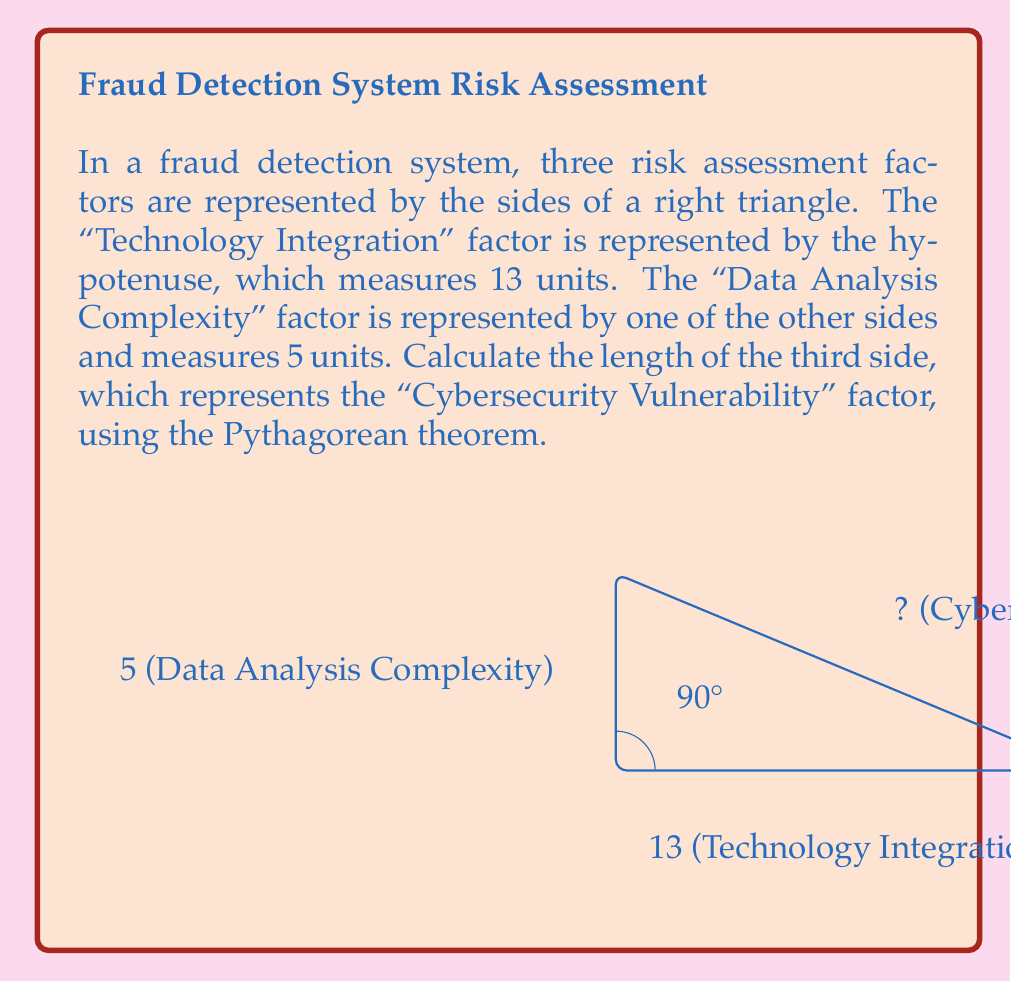Can you solve this math problem? To solve this problem, we'll use the Pythagorean theorem, which states that in a right triangle, the square of the hypotenuse is equal to the sum of squares of the other two sides.

Let's define our variables:
- $a$ = Cybersecurity Vulnerability (unknown side)
- $b$ = 5 (Data Analysis Complexity)
- $c$ = 13 (Technology Integration, hypotenuse)

The Pythagorean theorem is expressed as:

$$a^2 + b^2 = c^2$$

Substituting our known values:

$$a^2 + 5^2 = 13^2$$

Simplify:
$$a^2 + 25 = 169$$

Subtract 25 from both sides:
$$a^2 = 169 - 25 = 144$$

Take the square root of both sides:
$$a = \sqrt{144} = 12$$

Therefore, the length of the Cybersecurity Vulnerability side is 12 units.
Answer: 12 units 